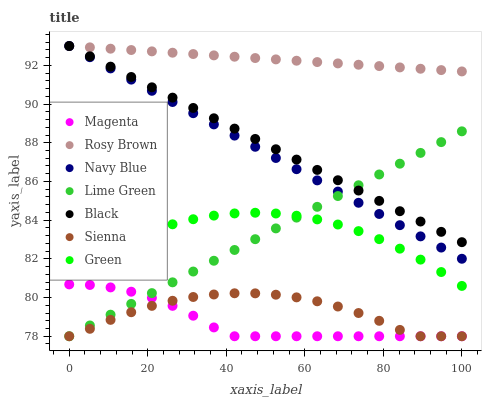Does Magenta have the minimum area under the curve?
Answer yes or no. Yes. Does Rosy Brown have the maximum area under the curve?
Answer yes or no. Yes. Does Sienna have the minimum area under the curve?
Answer yes or no. No. Does Sienna have the maximum area under the curve?
Answer yes or no. No. Is Rosy Brown the smoothest?
Answer yes or no. Yes. Is Sienna the roughest?
Answer yes or no. Yes. Is Sienna the smoothest?
Answer yes or no. No. Is Rosy Brown the roughest?
Answer yes or no. No. Does Sienna have the lowest value?
Answer yes or no. Yes. Does Rosy Brown have the lowest value?
Answer yes or no. No. Does Black have the highest value?
Answer yes or no. Yes. Does Sienna have the highest value?
Answer yes or no. No. Is Magenta less than Navy Blue?
Answer yes or no. Yes. Is Green greater than Sienna?
Answer yes or no. Yes. Does Lime Green intersect Navy Blue?
Answer yes or no. Yes. Is Lime Green less than Navy Blue?
Answer yes or no. No. Is Lime Green greater than Navy Blue?
Answer yes or no. No. Does Magenta intersect Navy Blue?
Answer yes or no. No. 